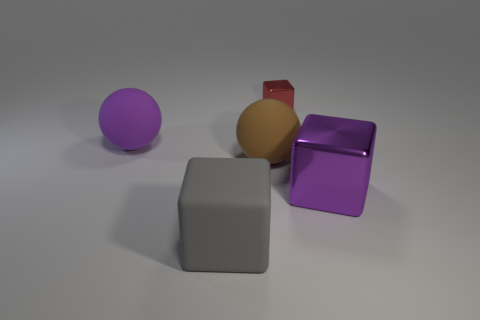What number of other objects are the same color as the large shiny thing?
Give a very brief answer. 1. What material is the tiny red object?
Offer a terse response. Metal. Is there a big purple thing?
Ensure brevity in your answer.  Yes. Is the number of gray things that are right of the gray matte thing the same as the number of green matte cylinders?
Your answer should be very brief. Yes. Are there any other things that are the same material as the big purple block?
Your answer should be very brief. Yes. What number of tiny things are matte cubes or metallic objects?
Offer a very short reply. 1. Is the material of the big block that is behind the gray rubber thing the same as the large gray thing?
Your response must be concise. No. What is the material of the large thing that is behind the sphere to the right of the big gray block?
Offer a very short reply. Rubber. What number of other red things have the same shape as the big metallic object?
Provide a short and direct response. 1. There is a matte ball on the right side of the rubber block that is on the right side of the purple object to the left of the large brown sphere; what size is it?
Keep it short and to the point. Large. 